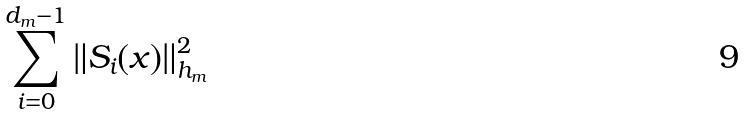Convert formula to latex. <formula><loc_0><loc_0><loc_500><loc_500>\sum _ { i = 0 } ^ { d _ { m } - 1 } \| S _ { i } ( x ) \| ^ { 2 } _ { h _ { m } }</formula> 